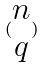<formula> <loc_0><loc_0><loc_500><loc_500>( \begin{matrix} n \\ q \end{matrix} )</formula> 